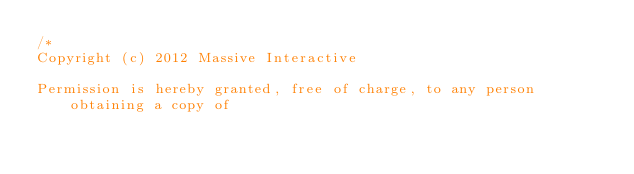<code> <loc_0><loc_0><loc_500><loc_500><_Haxe_>/*
Copyright (c) 2012 Massive Interactive

Permission is hereby granted, free of charge, to any person obtaining a copy of </code> 